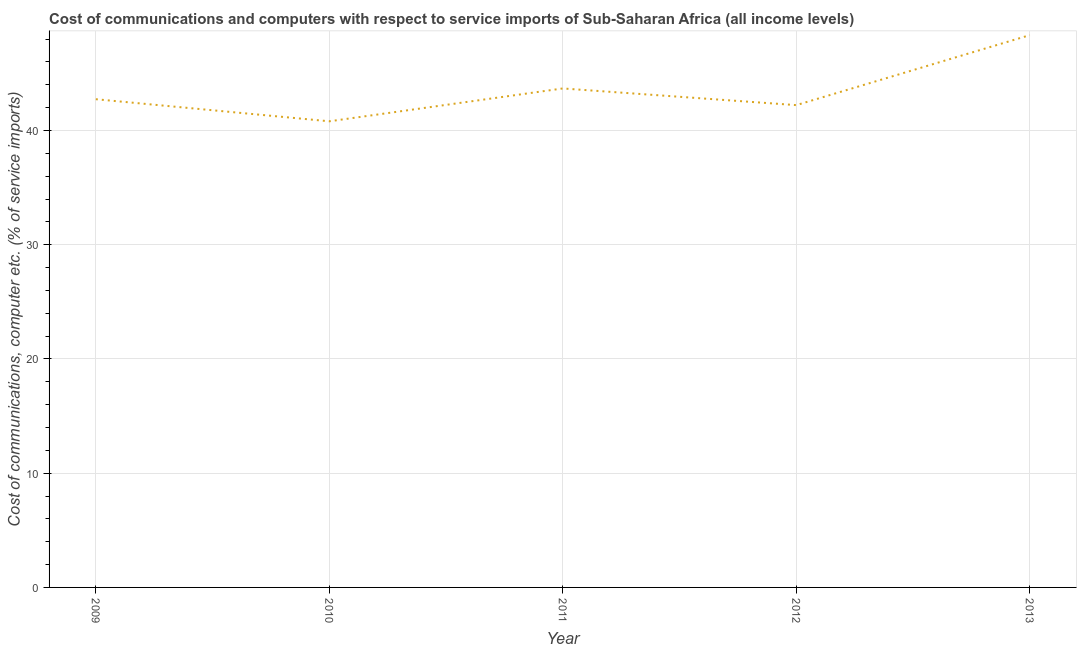What is the cost of communications and computer in 2012?
Offer a terse response. 42.22. Across all years, what is the maximum cost of communications and computer?
Keep it short and to the point. 48.35. Across all years, what is the minimum cost of communications and computer?
Offer a terse response. 40.81. In which year was the cost of communications and computer minimum?
Make the answer very short. 2010. What is the sum of the cost of communications and computer?
Your answer should be compact. 217.81. What is the difference between the cost of communications and computer in 2010 and 2013?
Offer a very short reply. -7.54. What is the average cost of communications and computer per year?
Keep it short and to the point. 43.56. What is the median cost of communications and computer?
Your answer should be very brief. 42.74. Do a majority of the years between 2009 and 2012 (inclusive) have cost of communications and computer greater than 46 %?
Your response must be concise. No. What is the ratio of the cost of communications and computer in 2012 to that in 2013?
Ensure brevity in your answer.  0.87. Is the difference between the cost of communications and computer in 2009 and 2011 greater than the difference between any two years?
Keep it short and to the point. No. What is the difference between the highest and the second highest cost of communications and computer?
Offer a very short reply. 4.67. What is the difference between the highest and the lowest cost of communications and computer?
Offer a terse response. 7.54. In how many years, is the cost of communications and computer greater than the average cost of communications and computer taken over all years?
Ensure brevity in your answer.  2. Does the cost of communications and computer monotonically increase over the years?
Keep it short and to the point. No. How many lines are there?
Offer a very short reply. 1. How many years are there in the graph?
Your answer should be very brief. 5. Does the graph contain grids?
Keep it short and to the point. Yes. What is the title of the graph?
Offer a terse response. Cost of communications and computers with respect to service imports of Sub-Saharan Africa (all income levels). What is the label or title of the X-axis?
Your answer should be very brief. Year. What is the label or title of the Y-axis?
Your answer should be very brief. Cost of communications, computer etc. (% of service imports). What is the Cost of communications, computer etc. (% of service imports) in 2009?
Make the answer very short. 42.74. What is the Cost of communications, computer etc. (% of service imports) of 2010?
Your answer should be compact. 40.81. What is the Cost of communications, computer etc. (% of service imports) in 2011?
Your answer should be very brief. 43.68. What is the Cost of communications, computer etc. (% of service imports) of 2012?
Ensure brevity in your answer.  42.22. What is the Cost of communications, computer etc. (% of service imports) of 2013?
Your response must be concise. 48.35. What is the difference between the Cost of communications, computer etc. (% of service imports) in 2009 and 2010?
Keep it short and to the point. 1.93. What is the difference between the Cost of communications, computer etc. (% of service imports) in 2009 and 2011?
Ensure brevity in your answer.  -0.94. What is the difference between the Cost of communications, computer etc. (% of service imports) in 2009 and 2012?
Offer a very short reply. 0.52. What is the difference between the Cost of communications, computer etc. (% of service imports) in 2009 and 2013?
Offer a very short reply. -5.61. What is the difference between the Cost of communications, computer etc. (% of service imports) in 2010 and 2011?
Give a very brief answer. -2.88. What is the difference between the Cost of communications, computer etc. (% of service imports) in 2010 and 2012?
Offer a terse response. -1.42. What is the difference between the Cost of communications, computer etc. (% of service imports) in 2010 and 2013?
Offer a terse response. -7.54. What is the difference between the Cost of communications, computer etc. (% of service imports) in 2011 and 2012?
Keep it short and to the point. 1.46. What is the difference between the Cost of communications, computer etc. (% of service imports) in 2011 and 2013?
Your answer should be compact. -4.67. What is the difference between the Cost of communications, computer etc. (% of service imports) in 2012 and 2013?
Your answer should be very brief. -6.13. What is the ratio of the Cost of communications, computer etc. (% of service imports) in 2009 to that in 2010?
Your response must be concise. 1.05. What is the ratio of the Cost of communications, computer etc. (% of service imports) in 2009 to that in 2013?
Make the answer very short. 0.88. What is the ratio of the Cost of communications, computer etc. (% of service imports) in 2010 to that in 2011?
Keep it short and to the point. 0.93. What is the ratio of the Cost of communications, computer etc. (% of service imports) in 2010 to that in 2013?
Make the answer very short. 0.84. What is the ratio of the Cost of communications, computer etc. (% of service imports) in 2011 to that in 2012?
Your answer should be very brief. 1.03. What is the ratio of the Cost of communications, computer etc. (% of service imports) in 2011 to that in 2013?
Provide a succinct answer. 0.9. What is the ratio of the Cost of communications, computer etc. (% of service imports) in 2012 to that in 2013?
Offer a very short reply. 0.87. 